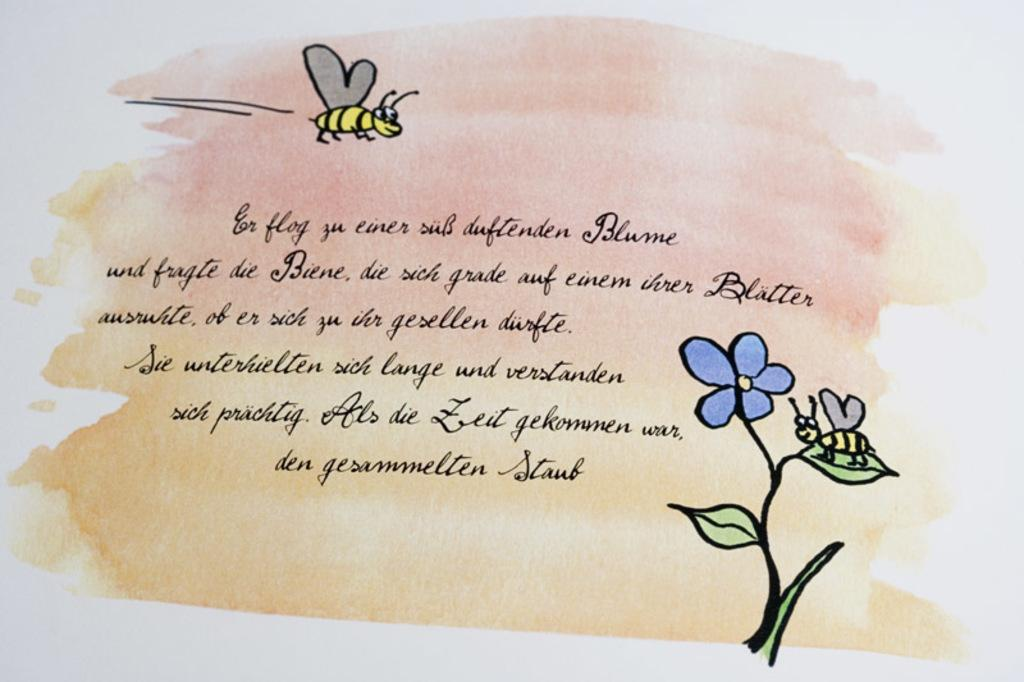What is depicted on the paper in the image? The paper contains drawings of insects, a flower, and leaves. What else can be found on the paper besides the drawings? There is writing on the paper. What is the taste of the idea depicted on the paper? There is no taste associated with the idea, as the image only contains drawings of insects, a flower, and leaves, along with writing. 